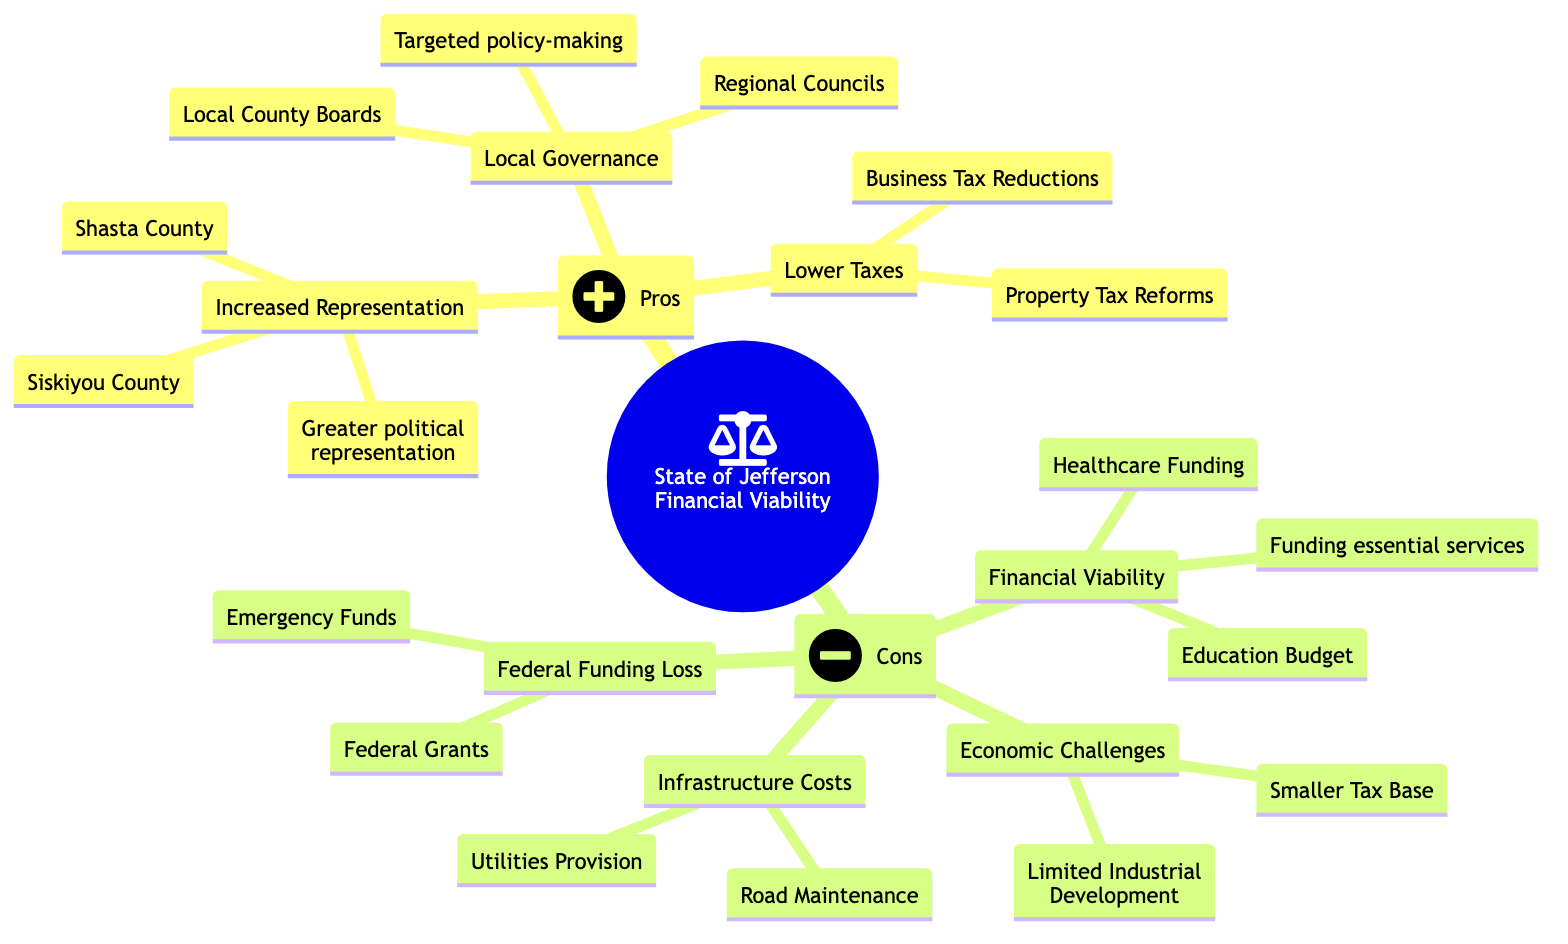What are the three pros listed in the diagram? The diagram enumerates three specific pros, which are located under the "Pros" category: Increased Representation, Local Governance, and Lower Taxes.
Answer: Increased Representation, Local Governance, Lower Taxes What is one example entity for Financial Viability? The Financial Viability section lists concerns about generating sufficient revenue, and it highlights specific example entities below it, including Healthcare Funding and Education Budget. One of these example entities is Healthcare Funding.
Answer: Healthcare Funding What is the main focus of the "Cons" section? The "Cons" section emphasizes the challenges associated with the financial feasibility of the State of Jefferson. It includes multiple specific concerns outlined as individual nodes beneath it, collectively focusing on potential drawbacks and financial issues.
Answer: Financial Viability How many pros are identified in the diagram? The diagram presents a total of three nodes categorized under "Pros" that specifically mention the advantages of the State of Jefferson, namely Increased Representation, Local Governance, and Lower Taxes. Counting these nodes gives a total of three.
Answer: 3 Which two entities are related to Local Governance? Under the "Local Governance" pro, the diagram lists two example entities: Local County Boards and Regional Councils. Both these entities are mentioned as part of the pros of having a separate governance structure.
Answer: Local County Boards, Regional Councils What potential financial issue is associated with Infrastructure Costs? The Infrastructure Costs section of the "Cons" identifies high expenses in developing and maintaining infrastructure. It specifically notes Road Maintenance and Utilities Provision as examples of this financial issue associated with infrastructure.
Answer: Road Maintenance What potential risk does the "Federal Funding Loss" node highlight? The "Federal Funding Loss" node expresses concerns regarding the possible loss of federal funding that California currently receives. It includes example entities like Federal Grants and Emergency Funds that illustrate this risk. Therefore, the key risk highlighted is the potential loss of these funds.
Answer: Loss of federal funding What is the relationship between Financial Viability and the ability to fund essential services? In the diagram, Financial Viability is a con that points directly to significant concerns about the ability to generate adequate revenue needed for funding essential services, illustrating a direct causal link that financial viability impacts service funding.
Answer: Direct link How does the size of the tax base relate to Economic Challenges? The Economic Challenges node notes that a smaller tax base contributes to financial instability, implying that limited economic resources hinder the ability to fund necessary public services, thereby connecting these two concepts.
Answer: Smaller tax base contributes to instability 